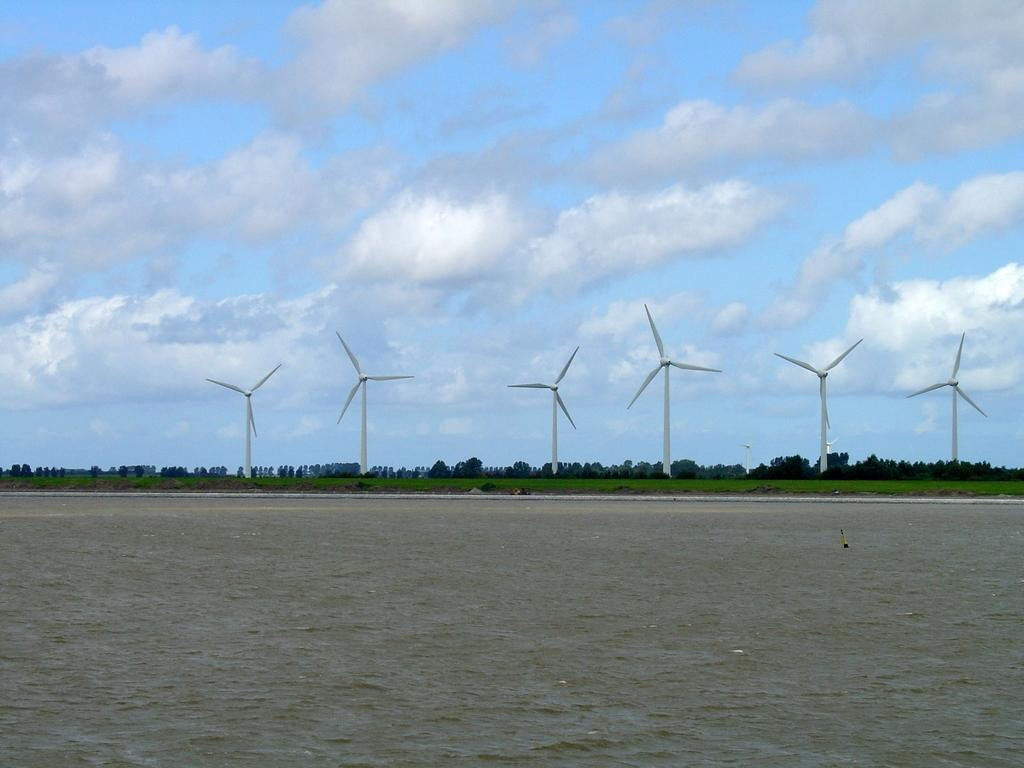What is visible in the image? Water is visible in the image. What can be seen in the background of the image? There are windmills and trees in the background of the image. What is the condition of the sky in the image? The sky is clear at the top of the image. What type of hand can be seen holding the vessel in the image? There is no hand or vessel present in the image. What sound can be heard from the bells in the image? There are no bells present in the image, so no sound can be heard. 